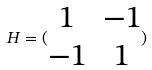<formula> <loc_0><loc_0><loc_500><loc_500>H = ( \begin{matrix} 1 & - 1 \\ - 1 & 1 \end{matrix} )</formula> 